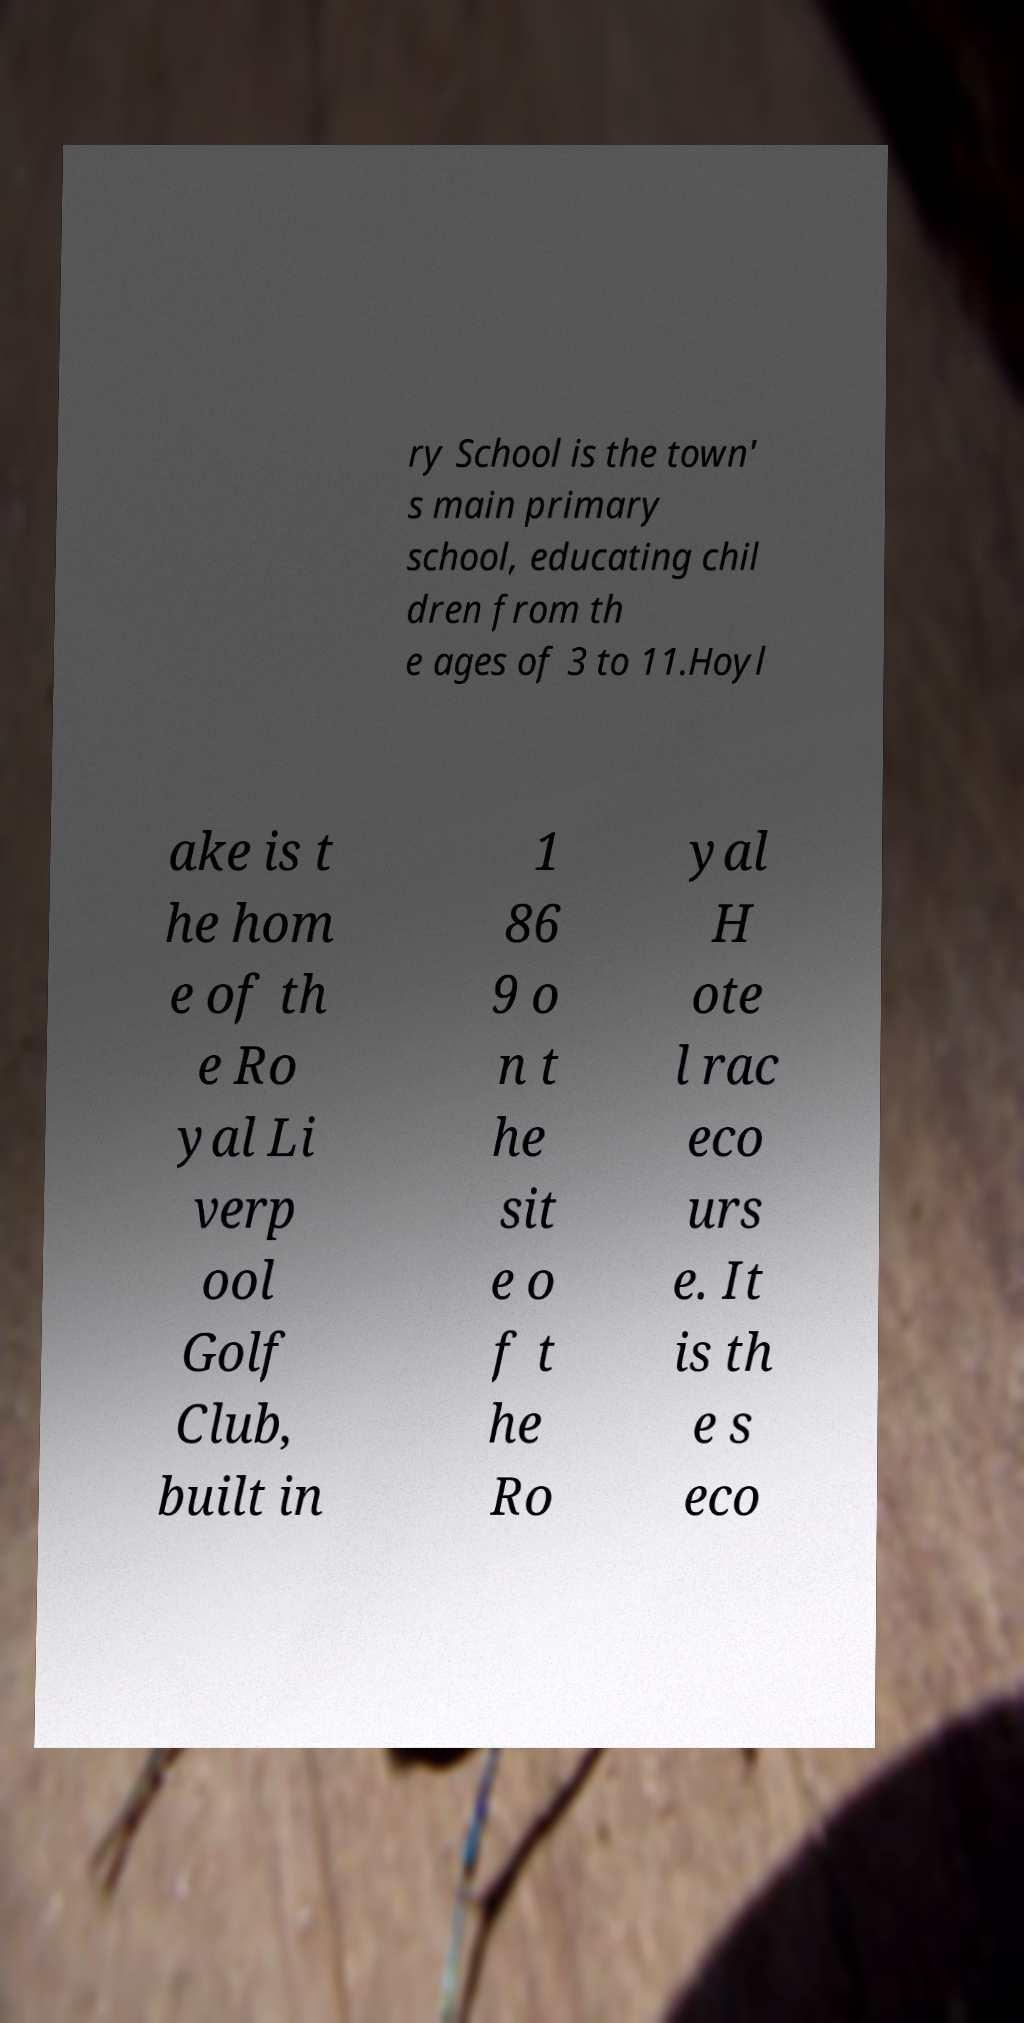There's text embedded in this image that I need extracted. Can you transcribe it verbatim? ry School is the town' s main primary school, educating chil dren from th e ages of 3 to 11.Hoyl ake is t he hom e of th e Ro yal Li verp ool Golf Club, built in 1 86 9 o n t he sit e o f t he Ro yal H ote l rac eco urs e. It is th e s eco 